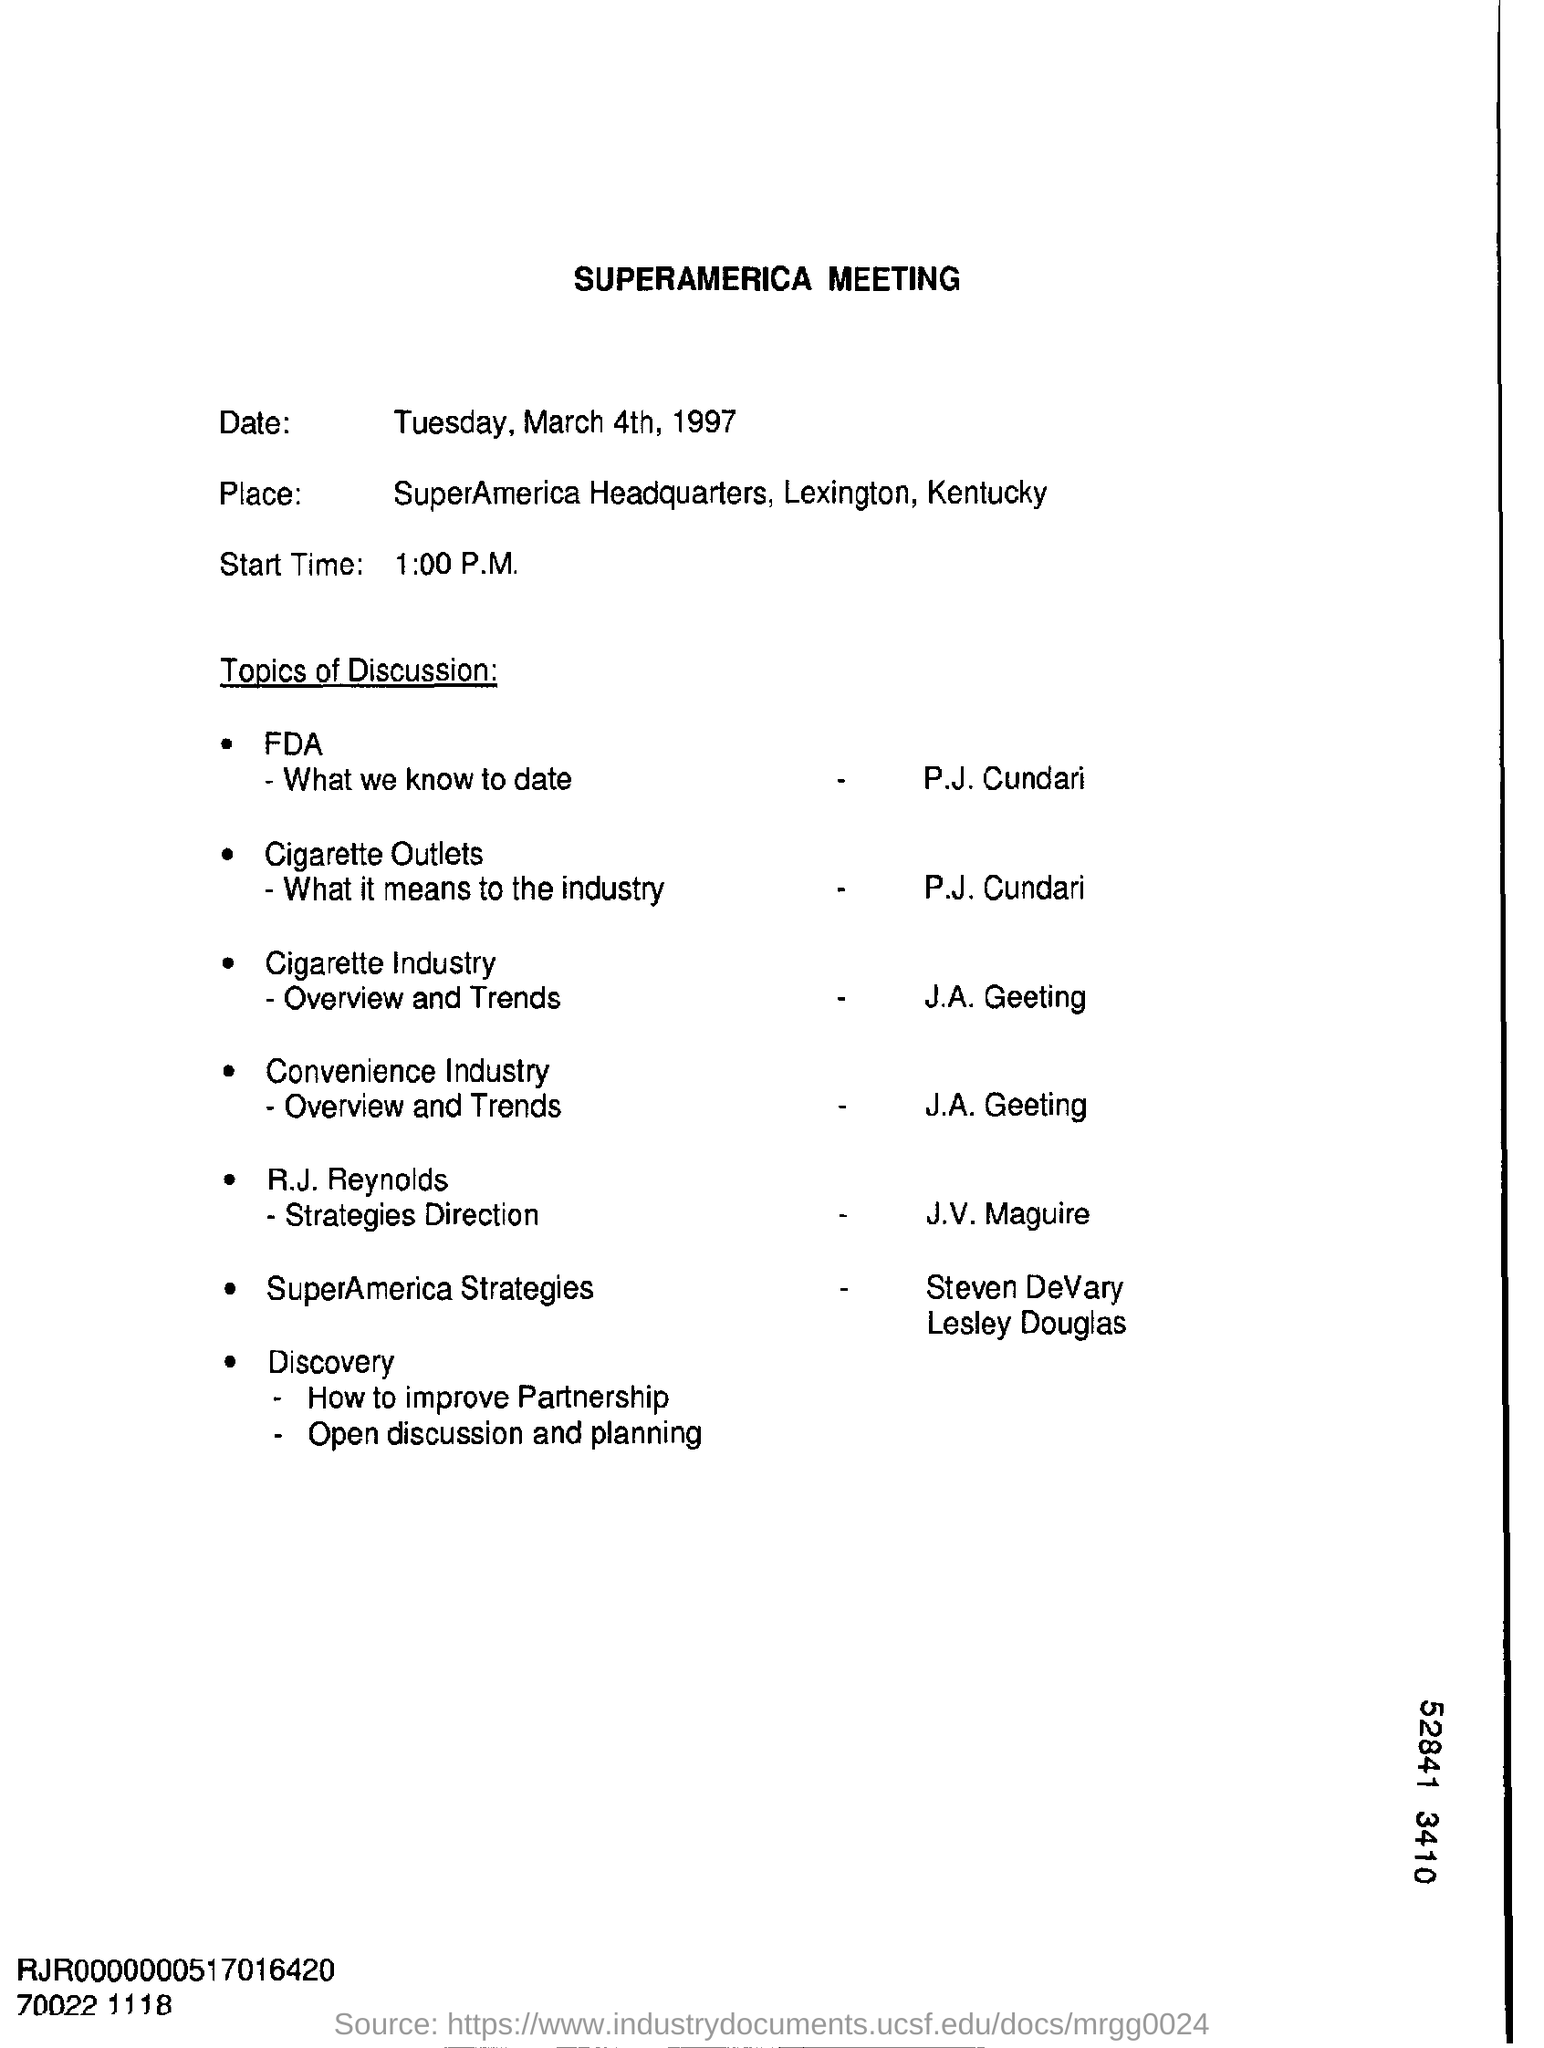What is the start time mention in the document?
Ensure brevity in your answer.  1:00 P.M. 